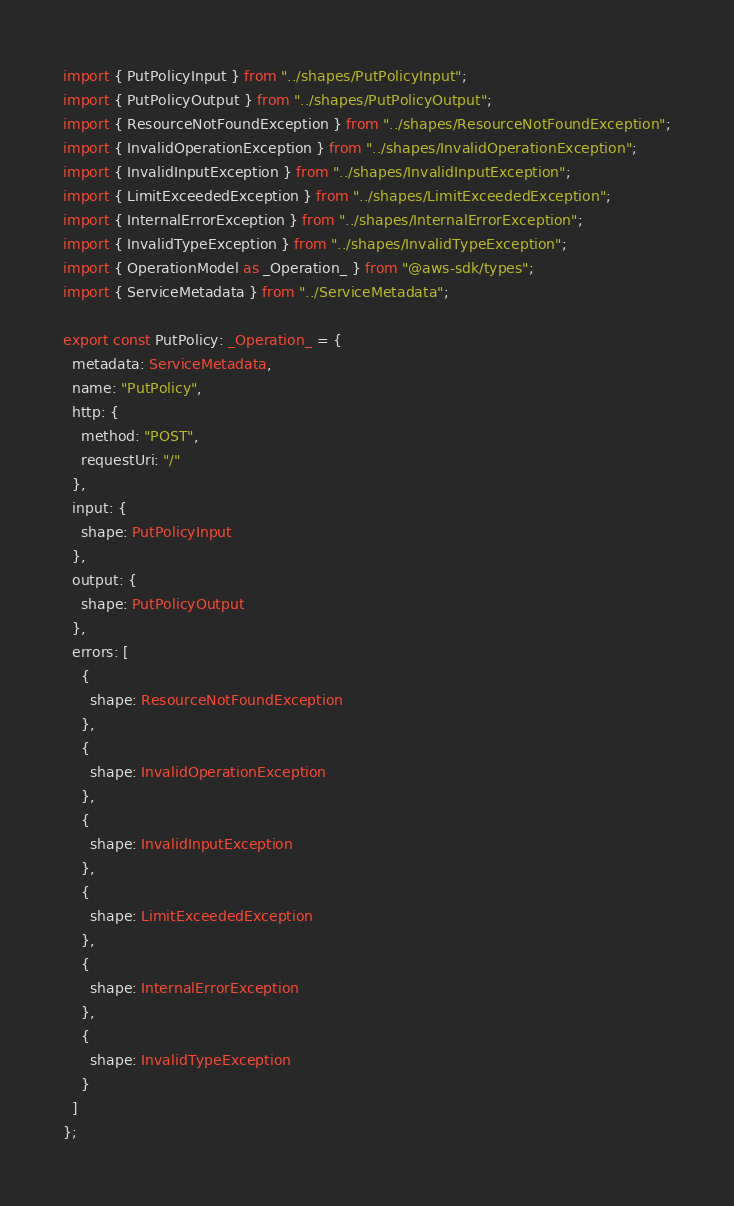<code> <loc_0><loc_0><loc_500><loc_500><_TypeScript_>import { PutPolicyInput } from "../shapes/PutPolicyInput";
import { PutPolicyOutput } from "../shapes/PutPolicyOutput";
import { ResourceNotFoundException } from "../shapes/ResourceNotFoundException";
import { InvalidOperationException } from "../shapes/InvalidOperationException";
import { InvalidInputException } from "../shapes/InvalidInputException";
import { LimitExceededException } from "../shapes/LimitExceededException";
import { InternalErrorException } from "../shapes/InternalErrorException";
import { InvalidTypeException } from "../shapes/InvalidTypeException";
import { OperationModel as _Operation_ } from "@aws-sdk/types";
import { ServiceMetadata } from "../ServiceMetadata";

export const PutPolicy: _Operation_ = {
  metadata: ServiceMetadata,
  name: "PutPolicy",
  http: {
    method: "POST",
    requestUri: "/"
  },
  input: {
    shape: PutPolicyInput
  },
  output: {
    shape: PutPolicyOutput
  },
  errors: [
    {
      shape: ResourceNotFoundException
    },
    {
      shape: InvalidOperationException
    },
    {
      shape: InvalidInputException
    },
    {
      shape: LimitExceededException
    },
    {
      shape: InternalErrorException
    },
    {
      shape: InvalidTypeException
    }
  ]
};
</code> 